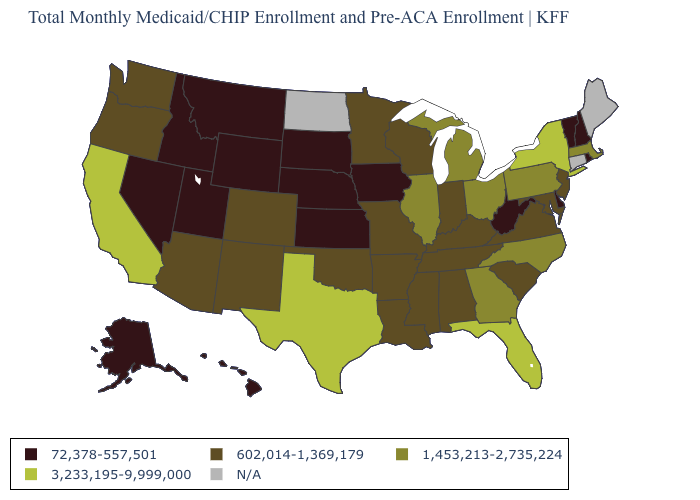What is the value of Colorado?
Write a very short answer. 602,014-1,369,179. What is the lowest value in the USA?
Keep it brief. 72,378-557,501. What is the value of New York?
Short answer required. 3,233,195-9,999,000. Is the legend a continuous bar?
Write a very short answer. No. Which states hav the highest value in the South?
Quick response, please. Florida, Texas. Does Massachusetts have the lowest value in the Northeast?
Be succinct. No. How many symbols are there in the legend?
Write a very short answer. 5. Which states hav the highest value in the MidWest?
Give a very brief answer. Illinois, Michigan, Ohio. What is the lowest value in the South?
Concise answer only. 72,378-557,501. What is the value of Kansas?
Be succinct. 72,378-557,501. Which states have the lowest value in the USA?
Short answer required. Alaska, Delaware, Hawaii, Idaho, Iowa, Kansas, Montana, Nebraska, Nevada, New Hampshire, Rhode Island, South Dakota, Utah, Vermont, West Virginia, Wyoming. Name the states that have a value in the range 1,453,213-2,735,224?
Write a very short answer. Georgia, Illinois, Massachusetts, Michigan, North Carolina, Ohio, Pennsylvania. Does Ohio have the lowest value in the MidWest?
Write a very short answer. No. 